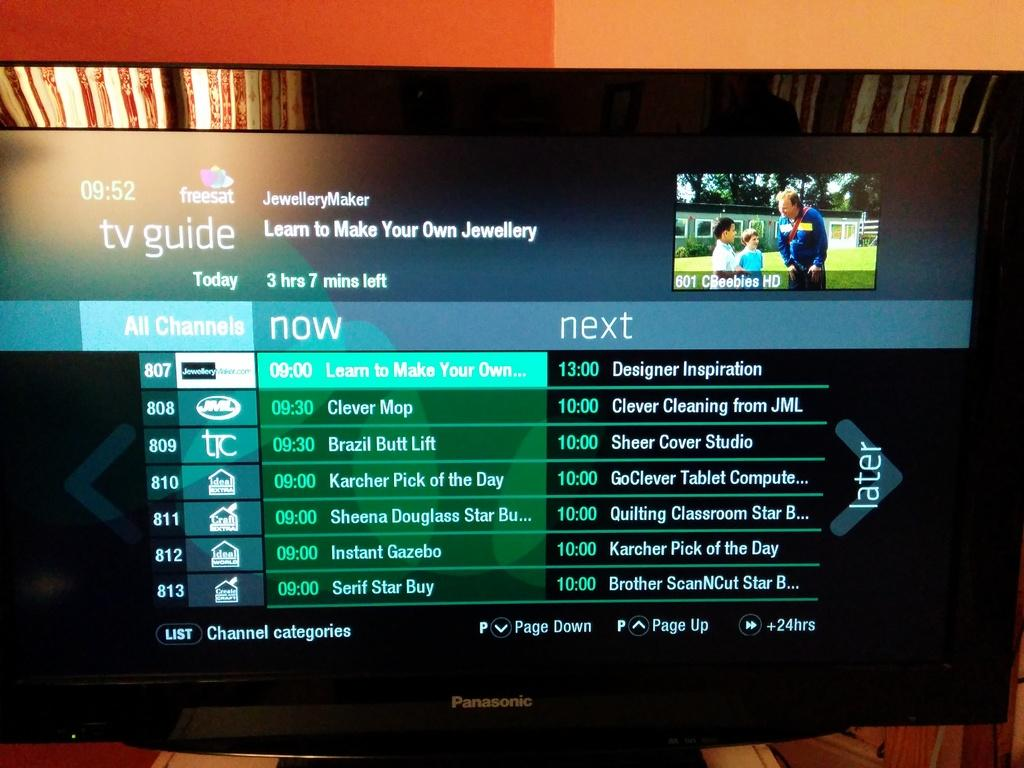<image>
Give a short and clear explanation of the subsequent image. A Panasonic television is displaying a tv channel guide on its screen. 